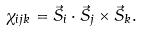<formula> <loc_0><loc_0><loc_500><loc_500>\chi _ { i j k } = \vec { S } _ { i } \cdot \vec { S } _ { j } \times \vec { S } _ { k } .</formula> 